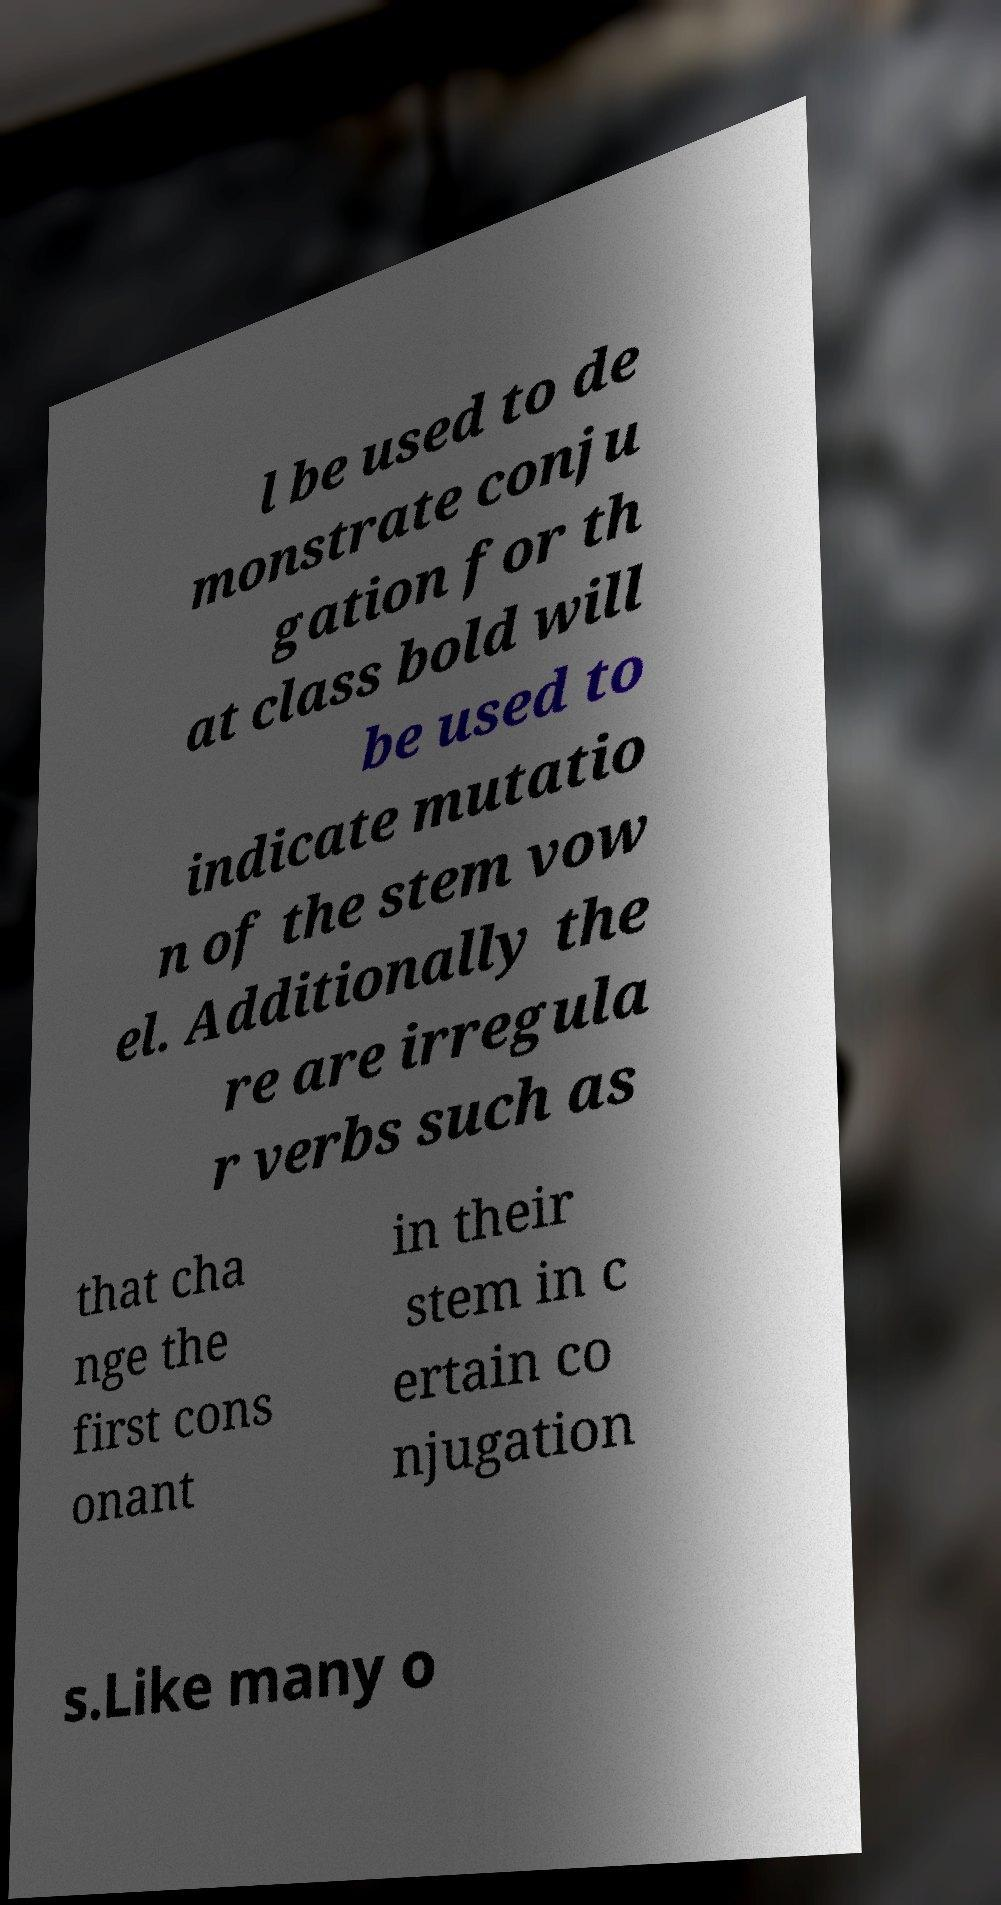There's text embedded in this image that I need extracted. Can you transcribe it verbatim? l be used to de monstrate conju gation for th at class bold will be used to indicate mutatio n of the stem vow el. Additionally the re are irregula r verbs such as that cha nge the first cons onant in their stem in c ertain co njugation s.Like many o 